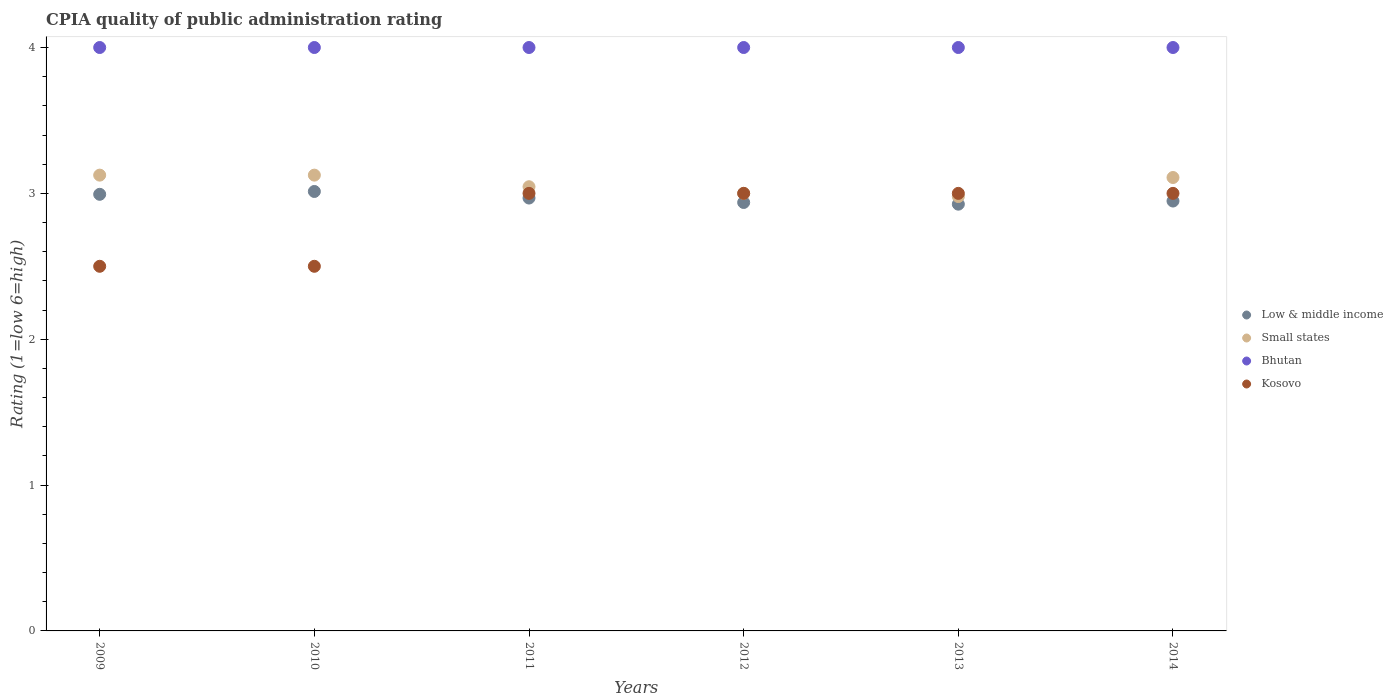What is the CPIA rating in Low & middle income in 2010?
Provide a succinct answer. 3.01. Across all years, what is the minimum CPIA rating in Kosovo?
Your response must be concise. 2.5. In which year was the CPIA rating in Small states minimum?
Your answer should be compact. 2013. What is the difference between the CPIA rating in Small states in 2014 and the CPIA rating in Low & middle income in 2010?
Give a very brief answer. 0.1. What is the average CPIA rating in Small states per year?
Make the answer very short. 3.06. In the year 2010, what is the difference between the CPIA rating in Kosovo and CPIA rating in Bhutan?
Your answer should be very brief. -1.5. In how many years, is the CPIA rating in Low & middle income greater than 2.2?
Your answer should be very brief. 6. What is the ratio of the CPIA rating in Low & middle income in 2011 to that in 2012?
Make the answer very short. 1.01. Is the difference between the CPIA rating in Kosovo in 2010 and 2013 greater than the difference between the CPIA rating in Bhutan in 2010 and 2013?
Keep it short and to the point. No. What is the difference between the highest and the lowest CPIA rating in Bhutan?
Provide a short and direct response. 0. In how many years, is the CPIA rating in Kosovo greater than the average CPIA rating in Kosovo taken over all years?
Provide a short and direct response. 4. Is the sum of the CPIA rating in Kosovo in 2010 and 2014 greater than the maximum CPIA rating in Low & middle income across all years?
Offer a terse response. Yes. Does the CPIA rating in Small states monotonically increase over the years?
Your answer should be compact. No. Is the CPIA rating in Small states strictly greater than the CPIA rating in Kosovo over the years?
Your answer should be very brief. No. Is the CPIA rating in Kosovo strictly less than the CPIA rating in Bhutan over the years?
Give a very brief answer. Yes. How many dotlines are there?
Provide a short and direct response. 4. How many years are there in the graph?
Offer a terse response. 6. Does the graph contain any zero values?
Ensure brevity in your answer.  No. Where does the legend appear in the graph?
Ensure brevity in your answer.  Center right. How many legend labels are there?
Provide a short and direct response. 4. What is the title of the graph?
Give a very brief answer. CPIA quality of public administration rating. What is the label or title of the Y-axis?
Offer a terse response. Rating (1=low 6=high). What is the Rating (1=low 6=high) of Low & middle income in 2009?
Provide a short and direct response. 2.99. What is the Rating (1=low 6=high) of Small states in 2009?
Keep it short and to the point. 3.12. What is the Rating (1=low 6=high) in Kosovo in 2009?
Your answer should be compact. 2.5. What is the Rating (1=low 6=high) of Low & middle income in 2010?
Your answer should be very brief. 3.01. What is the Rating (1=low 6=high) of Small states in 2010?
Your answer should be compact. 3.12. What is the Rating (1=low 6=high) in Bhutan in 2010?
Your response must be concise. 4. What is the Rating (1=low 6=high) of Kosovo in 2010?
Offer a very short reply. 2.5. What is the Rating (1=low 6=high) of Low & middle income in 2011?
Provide a short and direct response. 2.97. What is the Rating (1=low 6=high) of Small states in 2011?
Offer a terse response. 3.05. What is the Rating (1=low 6=high) of Kosovo in 2011?
Give a very brief answer. 3. What is the Rating (1=low 6=high) in Low & middle income in 2012?
Ensure brevity in your answer.  2.94. What is the Rating (1=low 6=high) of Small states in 2012?
Ensure brevity in your answer.  3. What is the Rating (1=low 6=high) of Kosovo in 2012?
Your answer should be very brief. 3. What is the Rating (1=low 6=high) of Low & middle income in 2013?
Provide a short and direct response. 2.93. What is the Rating (1=low 6=high) of Small states in 2013?
Make the answer very short. 2.98. What is the Rating (1=low 6=high) in Kosovo in 2013?
Ensure brevity in your answer.  3. What is the Rating (1=low 6=high) of Low & middle income in 2014?
Your answer should be very brief. 2.95. What is the Rating (1=low 6=high) in Small states in 2014?
Provide a succinct answer. 3.11. Across all years, what is the maximum Rating (1=low 6=high) of Low & middle income?
Offer a terse response. 3.01. Across all years, what is the maximum Rating (1=low 6=high) of Small states?
Your response must be concise. 3.12. Across all years, what is the maximum Rating (1=low 6=high) in Bhutan?
Offer a terse response. 4. Across all years, what is the maximum Rating (1=low 6=high) of Kosovo?
Your response must be concise. 3. Across all years, what is the minimum Rating (1=low 6=high) in Low & middle income?
Provide a short and direct response. 2.93. Across all years, what is the minimum Rating (1=low 6=high) in Small states?
Offer a very short reply. 2.98. Across all years, what is the minimum Rating (1=low 6=high) of Bhutan?
Provide a succinct answer. 4. What is the total Rating (1=low 6=high) in Low & middle income in the graph?
Offer a very short reply. 17.79. What is the total Rating (1=low 6=high) of Small states in the graph?
Your answer should be very brief. 18.38. What is the difference between the Rating (1=low 6=high) in Low & middle income in 2009 and that in 2010?
Give a very brief answer. -0.02. What is the difference between the Rating (1=low 6=high) of Bhutan in 2009 and that in 2010?
Your answer should be very brief. 0. What is the difference between the Rating (1=low 6=high) in Kosovo in 2009 and that in 2010?
Your response must be concise. 0. What is the difference between the Rating (1=low 6=high) in Low & middle income in 2009 and that in 2011?
Make the answer very short. 0.03. What is the difference between the Rating (1=low 6=high) of Small states in 2009 and that in 2011?
Give a very brief answer. 0.08. What is the difference between the Rating (1=low 6=high) in Bhutan in 2009 and that in 2011?
Your answer should be compact. 0. What is the difference between the Rating (1=low 6=high) of Low & middle income in 2009 and that in 2012?
Provide a succinct answer. 0.06. What is the difference between the Rating (1=low 6=high) of Small states in 2009 and that in 2012?
Make the answer very short. 0.12. What is the difference between the Rating (1=low 6=high) in Low & middle income in 2009 and that in 2013?
Provide a short and direct response. 0.07. What is the difference between the Rating (1=low 6=high) in Small states in 2009 and that in 2013?
Offer a terse response. 0.15. What is the difference between the Rating (1=low 6=high) of Low & middle income in 2009 and that in 2014?
Give a very brief answer. 0.05. What is the difference between the Rating (1=low 6=high) in Small states in 2009 and that in 2014?
Your answer should be very brief. 0.02. What is the difference between the Rating (1=low 6=high) in Bhutan in 2009 and that in 2014?
Your answer should be very brief. 0. What is the difference between the Rating (1=low 6=high) in Kosovo in 2009 and that in 2014?
Keep it short and to the point. -0.5. What is the difference between the Rating (1=low 6=high) in Low & middle income in 2010 and that in 2011?
Ensure brevity in your answer.  0.04. What is the difference between the Rating (1=low 6=high) in Small states in 2010 and that in 2011?
Offer a terse response. 0.08. What is the difference between the Rating (1=low 6=high) in Bhutan in 2010 and that in 2011?
Your answer should be compact. 0. What is the difference between the Rating (1=low 6=high) of Low & middle income in 2010 and that in 2012?
Your answer should be compact. 0.08. What is the difference between the Rating (1=low 6=high) in Low & middle income in 2010 and that in 2013?
Offer a terse response. 0.09. What is the difference between the Rating (1=low 6=high) in Small states in 2010 and that in 2013?
Provide a short and direct response. 0.15. What is the difference between the Rating (1=low 6=high) of Low & middle income in 2010 and that in 2014?
Offer a terse response. 0.07. What is the difference between the Rating (1=low 6=high) of Small states in 2010 and that in 2014?
Your response must be concise. 0.02. What is the difference between the Rating (1=low 6=high) of Kosovo in 2010 and that in 2014?
Offer a terse response. -0.5. What is the difference between the Rating (1=low 6=high) in Low & middle income in 2011 and that in 2012?
Provide a succinct answer. 0.03. What is the difference between the Rating (1=low 6=high) in Small states in 2011 and that in 2012?
Provide a short and direct response. 0.05. What is the difference between the Rating (1=low 6=high) of Kosovo in 2011 and that in 2012?
Offer a terse response. 0. What is the difference between the Rating (1=low 6=high) in Low & middle income in 2011 and that in 2013?
Keep it short and to the point. 0.04. What is the difference between the Rating (1=low 6=high) in Small states in 2011 and that in 2013?
Provide a succinct answer. 0.07. What is the difference between the Rating (1=low 6=high) in Bhutan in 2011 and that in 2013?
Provide a short and direct response. 0. What is the difference between the Rating (1=low 6=high) of Kosovo in 2011 and that in 2013?
Offer a terse response. 0. What is the difference between the Rating (1=low 6=high) in Low & middle income in 2011 and that in 2014?
Provide a short and direct response. 0.02. What is the difference between the Rating (1=low 6=high) in Small states in 2011 and that in 2014?
Make the answer very short. -0.06. What is the difference between the Rating (1=low 6=high) of Low & middle income in 2012 and that in 2013?
Ensure brevity in your answer.  0.01. What is the difference between the Rating (1=low 6=high) in Small states in 2012 and that in 2013?
Ensure brevity in your answer.  0.02. What is the difference between the Rating (1=low 6=high) of Kosovo in 2012 and that in 2013?
Keep it short and to the point. 0. What is the difference between the Rating (1=low 6=high) in Low & middle income in 2012 and that in 2014?
Give a very brief answer. -0.01. What is the difference between the Rating (1=low 6=high) of Small states in 2012 and that in 2014?
Your answer should be compact. -0.11. What is the difference between the Rating (1=low 6=high) of Bhutan in 2012 and that in 2014?
Your response must be concise. 0. What is the difference between the Rating (1=low 6=high) in Low & middle income in 2013 and that in 2014?
Offer a very short reply. -0.02. What is the difference between the Rating (1=low 6=high) in Small states in 2013 and that in 2014?
Keep it short and to the point. -0.13. What is the difference between the Rating (1=low 6=high) of Bhutan in 2013 and that in 2014?
Provide a succinct answer. 0. What is the difference between the Rating (1=low 6=high) of Kosovo in 2013 and that in 2014?
Make the answer very short. 0. What is the difference between the Rating (1=low 6=high) of Low & middle income in 2009 and the Rating (1=low 6=high) of Small states in 2010?
Ensure brevity in your answer.  -0.13. What is the difference between the Rating (1=low 6=high) of Low & middle income in 2009 and the Rating (1=low 6=high) of Bhutan in 2010?
Give a very brief answer. -1.01. What is the difference between the Rating (1=low 6=high) of Low & middle income in 2009 and the Rating (1=low 6=high) of Kosovo in 2010?
Your response must be concise. 0.49. What is the difference between the Rating (1=low 6=high) of Small states in 2009 and the Rating (1=low 6=high) of Bhutan in 2010?
Give a very brief answer. -0.88. What is the difference between the Rating (1=low 6=high) in Small states in 2009 and the Rating (1=low 6=high) in Kosovo in 2010?
Offer a very short reply. 0.62. What is the difference between the Rating (1=low 6=high) in Low & middle income in 2009 and the Rating (1=low 6=high) in Small states in 2011?
Make the answer very short. -0.05. What is the difference between the Rating (1=low 6=high) of Low & middle income in 2009 and the Rating (1=low 6=high) of Bhutan in 2011?
Provide a short and direct response. -1.01. What is the difference between the Rating (1=low 6=high) in Low & middle income in 2009 and the Rating (1=low 6=high) in Kosovo in 2011?
Your answer should be compact. -0.01. What is the difference between the Rating (1=low 6=high) of Small states in 2009 and the Rating (1=low 6=high) of Bhutan in 2011?
Keep it short and to the point. -0.88. What is the difference between the Rating (1=low 6=high) of Small states in 2009 and the Rating (1=low 6=high) of Kosovo in 2011?
Provide a succinct answer. 0.12. What is the difference between the Rating (1=low 6=high) in Low & middle income in 2009 and the Rating (1=low 6=high) in Small states in 2012?
Offer a very short reply. -0.01. What is the difference between the Rating (1=low 6=high) of Low & middle income in 2009 and the Rating (1=low 6=high) of Bhutan in 2012?
Give a very brief answer. -1.01. What is the difference between the Rating (1=low 6=high) of Low & middle income in 2009 and the Rating (1=low 6=high) of Kosovo in 2012?
Your response must be concise. -0.01. What is the difference between the Rating (1=low 6=high) of Small states in 2009 and the Rating (1=low 6=high) of Bhutan in 2012?
Ensure brevity in your answer.  -0.88. What is the difference between the Rating (1=low 6=high) of Small states in 2009 and the Rating (1=low 6=high) of Kosovo in 2012?
Give a very brief answer. 0.12. What is the difference between the Rating (1=low 6=high) of Low & middle income in 2009 and the Rating (1=low 6=high) of Small states in 2013?
Give a very brief answer. 0.02. What is the difference between the Rating (1=low 6=high) of Low & middle income in 2009 and the Rating (1=low 6=high) of Bhutan in 2013?
Provide a short and direct response. -1.01. What is the difference between the Rating (1=low 6=high) of Low & middle income in 2009 and the Rating (1=low 6=high) of Kosovo in 2013?
Your answer should be compact. -0.01. What is the difference between the Rating (1=low 6=high) in Small states in 2009 and the Rating (1=low 6=high) in Bhutan in 2013?
Your answer should be compact. -0.88. What is the difference between the Rating (1=low 6=high) of Small states in 2009 and the Rating (1=low 6=high) of Kosovo in 2013?
Ensure brevity in your answer.  0.12. What is the difference between the Rating (1=low 6=high) of Low & middle income in 2009 and the Rating (1=low 6=high) of Small states in 2014?
Make the answer very short. -0.12. What is the difference between the Rating (1=low 6=high) of Low & middle income in 2009 and the Rating (1=low 6=high) of Bhutan in 2014?
Make the answer very short. -1.01. What is the difference between the Rating (1=low 6=high) of Low & middle income in 2009 and the Rating (1=low 6=high) of Kosovo in 2014?
Offer a very short reply. -0.01. What is the difference between the Rating (1=low 6=high) of Small states in 2009 and the Rating (1=low 6=high) of Bhutan in 2014?
Ensure brevity in your answer.  -0.88. What is the difference between the Rating (1=low 6=high) in Bhutan in 2009 and the Rating (1=low 6=high) in Kosovo in 2014?
Ensure brevity in your answer.  1. What is the difference between the Rating (1=low 6=high) of Low & middle income in 2010 and the Rating (1=low 6=high) of Small states in 2011?
Provide a succinct answer. -0.03. What is the difference between the Rating (1=low 6=high) of Low & middle income in 2010 and the Rating (1=low 6=high) of Bhutan in 2011?
Ensure brevity in your answer.  -0.99. What is the difference between the Rating (1=low 6=high) of Low & middle income in 2010 and the Rating (1=low 6=high) of Kosovo in 2011?
Your response must be concise. 0.01. What is the difference between the Rating (1=low 6=high) in Small states in 2010 and the Rating (1=low 6=high) in Bhutan in 2011?
Provide a short and direct response. -0.88. What is the difference between the Rating (1=low 6=high) of Small states in 2010 and the Rating (1=low 6=high) of Kosovo in 2011?
Your answer should be very brief. 0.12. What is the difference between the Rating (1=low 6=high) in Bhutan in 2010 and the Rating (1=low 6=high) in Kosovo in 2011?
Offer a terse response. 1. What is the difference between the Rating (1=low 6=high) in Low & middle income in 2010 and the Rating (1=low 6=high) in Small states in 2012?
Offer a very short reply. 0.01. What is the difference between the Rating (1=low 6=high) of Low & middle income in 2010 and the Rating (1=low 6=high) of Bhutan in 2012?
Your answer should be compact. -0.99. What is the difference between the Rating (1=low 6=high) in Low & middle income in 2010 and the Rating (1=low 6=high) in Kosovo in 2012?
Your answer should be very brief. 0.01. What is the difference between the Rating (1=low 6=high) in Small states in 2010 and the Rating (1=low 6=high) in Bhutan in 2012?
Make the answer very short. -0.88. What is the difference between the Rating (1=low 6=high) of Low & middle income in 2010 and the Rating (1=low 6=high) of Small states in 2013?
Give a very brief answer. 0.03. What is the difference between the Rating (1=low 6=high) in Low & middle income in 2010 and the Rating (1=low 6=high) in Bhutan in 2013?
Keep it short and to the point. -0.99. What is the difference between the Rating (1=low 6=high) in Low & middle income in 2010 and the Rating (1=low 6=high) in Kosovo in 2013?
Provide a short and direct response. 0.01. What is the difference between the Rating (1=low 6=high) in Small states in 2010 and the Rating (1=low 6=high) in Bhutan in 2013?
Offer a terse response. -0.88. What is the difference between the Rating (1=low 6=high) of Bhutan in 2010 and the Rating (1=low 6=high) of Kosovo in 2013?
Your answer should be very brief. 1. What is the difference between the Rating (1=low 6=high) in Low & middle income in 2010 and the Rating (1=low 6=high) in Small states in 2014?
Your response must be concise. -0.1. What is the difference between the Rating (1=low 6=high) of Low & middle income in 2010 and the Rating (1=low 6=high) of Bhutan in 2014?
Offer a terse response. -0.99. What is the difference between the Rating (1=low 6=high) of Low & middle income in 2010 and the Rating (1=low 6=high) of Kosovo in 2014?
Keep it short and to the point. 0.01. What is the difference between the Rating (1=low 6=high) of Small states in 2010 and the Rating (1=low 6=high) of Bhutan in 2014?
Ensure brevity in your answer.  -0.88. What is the difference between the Rating (1=low 6=high) of Small states in 2010 and the Rating (1=low 6=high) of Kosovo in 2014?
Keep it short and to the point. 0.12. What is the difference between the Rating (1=low 6=high) in Low & middle income in 2011 and the Rating (1=low 6=high) in Small states in 2012?
Offer a very short reply. -0.03. What is the difference between the Rating (1=low 6=high) in Low & middle income in 2011 and the Rating (1=low 6=high) in Bhutan in 2012?
Provide a short and direct response. -1.03. What is the difference between the Rating (1=low 6=high) in Low & middle income in 2011 and the Rating (1=low 6=high) in Kosovo in 2012?
Offer a very short reply. -0.03. What is the difference between the Rating (1=low 6=high) of Small states in 2011 and the Rating (1=low 6=high) of Bhutan in 2012?
Make the answer very short. -0.95. What is the difference between the Rating (1=low 6=high) of Small states in 2011 and the Rating (1=low 6=high) of Kosovo in 2012?
Offer a terse response. 0.05. What is the difference between the Rating (1=low 6=high) in Low & middle income in 2011 and the Rating (1=low 6=high) in Small states in 2013?
Ensure brevity in your answer.  -0.01. What is the difference between the Rating (1=low 6=high) in Low & middle income in 2011 and the Rating (1=low 6=high) in Bhutan in 2013?
Keep it short and to the point. -1.03. What is the difference between the Rating (1=low 6=high) in Low & middle income in 2011 and the Rating (1=low 6=high) in Kosovo in 2013?
Your answer should be very brief. -0.03. What is the difference between the Rating (1=low 6=high) of Small states in 2011 and the Rating (1=low 6=high) of Bhutan in 2013?
Give a very brief answer. -0.95. What is the difference between the Rating (1=low 6=high) in Small states in 2011 and the Rating (1=low 6=high) in Kosovo in 2013?
Provide a succinct answer. 0.05. What is the difference between the Rating (1=low 6=high) in Bhutan in 2011 and the Rating (1=low 6=high) in Kosovo in 2013?
Offer a very short reply. 1. What is the difference between the Rating (1=low 6=high) in Low & middle income in 2011 and the Rating (1=low 6=high) in Small states in 2014?
Provide a short and direct response. -0.14. What is the difference between the Rating (1=low 6=high) of Low & middle income in 2011 and the Rating (1=low 6=high) of Bhutan in 2014?
Ensure brevity in your answer.  -1.03. What is the difference between the Rating (1=low 6=high) of Low & middle income in 2011 and the Rating (1=low 6=high) of Kosovo in 2014?
Keep it short and to the point. -0.03. What is the difference between the Rating (1=low 6=high) of Small states in 2011 and the Rating (1=low 6=high) of Bhutan in 2014?
Give a very brief answer. -0.95. What is the difference between the Rating (1=low 6=high) in Small states in 2011 and the Rating (1=low 6=high) in Kosovo in 2014?
Your answer should be compact. 0.05. What is the difference between the Rating (1=low 6=high) in Low & middle income in 2012 and the Rating (1=low 6=high) in Small states in 2013?
Ensure brevity in your answer.  -0.04. What is the difference between the Rating (1=low 6=high) in Low & middle income in 2012 and the Rating (1=low 6=high) in Bhutan in 2013?
Your answer should be very brief. -1.06. What is the difference between the Rating (1=low 6=high) of Low & middle income in 2012 and the Rating (1=low 6=high) of Kosovo in 2013?
Your answer should be compact. -0.06. What is the difference between the Rating (1=low 6=high) in Small states in 2012 and the Rating (1=low 6=high) in Bhutan in 2013?
Your answer should be compact. -1. What is the difference between the Rating (1=low 6=high) in Small states in 2012 and the Rating (1=low 6=high) in Kosovo in 2013?
Your response must be concise. 0. What is the difference between the Rating (1=low 6=high) in Bhutan in 2012 and the Rating (1=low 6=high) in Kosovo in 2013?
Ensure brevity in your answer.  1. What is the difference between the Rating (1=low 6=high) of Low & middle income in 2012 and the Rating (1=low 6=high) of Small states in 2014?
Your answer should be compact. -0.17. What is the difference between the Rating (1=low 6=high) of Low & middle income in 2012 and the Rating (1=low 6=high) of Bhutan in 2014?
Provide a short and direct response. -1.06. What is the difference between the Rating (1=low 6=high) in Low & middle income in 2012 and the Rating (1=low 6=high) in Kosovo in 2014?
Your answer should be compact. -0.06. What is the difference between the Rating (1=low 6=high) in Bhutan in 2012 and the Rating (1=low 6=high) in Kosovo in 2014?
Your answer should be compact. 1. What is the difference between the Rating (1=low 6=high) of Low & middle income in 2013 and the Rating (1=low 6=high) of Small states in 2014?
Your response must be concise. -0.18. What is the difference between the Rating (1=low 6=high) in Low & middle income in 2013 and the Rating (1=low 6=high) in Bhutan in 2014?
Your response must be concise. -1.07. What is the difference between the Rating (1=low 6=high) in Low & middle income in 2013 and the Rating (1=low 6=high) in Kosovo in 2014?
Your answer should be very brief. -0.07. What is the difference between the Rating (1=low 6=high) of Small states in 2013 and the Rating (1=low 6=high) of Bhutan in 2014?
Offer a very short reply. -1.02. What is the difference between the Rating (1=low 6=high) in Small states in 2013 and the Rating (1=low 6=high) in Kosovo in 2014?
Your answer should be compact. -0.02. What is the average Rating (1=low 6=high) of Low & middle income per year?
Give a very brief answer. 2.96. What is the average Rating (1=low 6=high) of Small states per year?
Your response must be concise. 3.06. What is the average Rating (1=low 6=high) of Kosovo per year?
Your answer should be compact. 2.83. In the year 2009, what is the difference between the Rating (1=low 6=high) in Low & middle income and Rating (1=low 6=high) in Small states?
Provide a succinct answer. -0.13. In the year 2009, what is the difference between the Rating (1=low 6=high) in Low & middle income and Rating (1=low 6=high) in Bhutan?
Keep it short and to the point. -1.01. In the year 2009, what is the difference between the Rating (1=low 6=high) of Low & middle income and Rating (1=low 6=high) of Kosovo?
Give a very brief answer. 0.49. In the year 2009, what is the difference between the Rating (1=low 6=high) in Small states and Rating (1=low 6=high) in Bhutan?
Give a very brief answer. -0.88. In the year 2009, what is the difference between the Rating (1=low 6=high) in Bhutan and Rating (1=low 6=high) in Kosovo?
Offer a terse response. 1.5. In the year 2010, what is the difference between the Rating (1=low 6=high) of Low & middle income and Rating (1=low 6=high) of Small states?
Offer a very short reply. -0.11. In the year 2010, what is the difference between the Rating (1=low 6=high) in Low & middle income and Rating (1=low 6=high) in Bhutan?
Make the answer very short. -0.99. In the year 2010, what is the difference between the Rating (1=low 6=high) in Low & middle income and Rating (1=low 6=high) in Kosovo?
Make the answer very short. 0.51. In the year 2010, what is the difference between the Rating (1=low 6=high) of Small states and Rating (1=low 6=high) of Bhutan?
Keep it short and to the point. -0.88. In the year 2010, what is the difference between the Rating (1=low 6=high) in Bhutan and Rating (1=low 6=high) in Kosovo?
Provide a succinct answer. 1.5. In the year 2011, what is the difference between the Rating (1=low 6=high) in Low & middle income and Rating (1=low 6=high) in Small states?
Offer a very short reply. -0.08. In the year 2011, what is the difference between the Rating (1=low 6=high) in Low & middle income and Rating (1=low 6=high) in Bhutan?
Give a very brief answer. -1.03. In the year 2011, what is the difference between the Rating (1=low 6=high) in Low & middle income and Rating (1=low 6=high) in Kosovo?
Your answer should be compact. -0.03. In the year 2011, what is the difference between the Rating (1=low 6=high) of Small states and Rating (1=low 6=high) of Bhutan?
Your answer should be compact. -0.95. In the year 2011, what is the difference between the Rating (1=low 6=high) of Small states and Rating (1=low 6=high) of Kosovo?
Make the answer very short. 0.05. In the year 2012, what is the difference between the Rating (1=low 6=high) of Low & middle income and Rating (1=low 6=high) of Small states?
Provide a succinct answer. -0.06. In the year 2012, what is the difference between the Rating (1=low 6=high) in Low & middle income and Rating (1=low 6=high) in Bhutan?
Ensure brevity in your answer.  -1.06. In the year 2012, what is the difference between the Rating (1=low 6=high) of Low & middle income and Rating (1=low 6=high) of Kosovo?
Provide a short and direct response. -0.06. In the year 2012, what is the difference between the Rating (1=low 6=high) of Small states and Rating (1=low 6=high) of Bhutan?
Offer a very short reply. -1. In the year 2013, what is the difference between the Rating (1=low 6=high) in Low & middle income and Rating (1=low 6=high) in Small states?
Provide a short and direct response. -0.05. In the year 2013, what is the difference between the Rating (1=low 6=high) in Low & middle income and Rating (1=low 6=high) in Bhutan?
Provide a short and direct response. -1.07. In the year 2013, what is the difference between the Rating (1=low 6=high) in Low & middle income and Rating (1=low 6=high) in Kosovo?
Your response must be concise. -0.07. In the year 2013, what is the difference between the Rating (1=low 6=high) in Small states and Rating (1=low 6=high) in Bhutan?
Offer a very short reply. -1.02. In the year 2013, what is the difference between the Rating (1=low 6=high) of Small states and Rating (1=low 6=high) of Kosovo?
Keep it short and to the point. -0.02. In the year 2014, what is the difference between the Rating (1=low 6=high) of Low & middle income and Rating (1=low 6=high) of Small states?
Your response must be concise. -0.16. In the year 2014, what is the difference between the Rating (1=low 6=high) of Low & middle income and Rating (1=low 6=high) of Bhutan?
Keep it short and to the point. -1.05. In the year 2014, what is the difference between the Rating (1=low 6=high) in Low & middle income and Rating (1=low 6=high) in Kosovo?
Ensure brevity in your answer.  -0.05. In the year 2014, what is the difference between the Rating (1=low 6=high) in Small states and Rating (1=low 6=high) in Bhutan?
Your response must be concise. -0.89. In the year 2014, what is the difference between the Rating (1=low 6=high) in Small states and Rating (1=low 6=high) in Kosovo?
Your answer should be very brief. 0.11. What is the ratio of the Rating (1=low 6=high) of Low & middle income in 2009 to that in 2010?
Provide a short and direct response. 0.99. What is the ratio of the Rating (1=low 6=high) of Small states in 2009 to that in 2010?
Your answer should be compact. 1. What is the ratio of the Rating (1=low 6=high) in Bhutan in 2009 to that in 2010?
Ensure brevity in your answer.  1. What is the ratio of the Rating (1=low 6=high) of Kosovo in 2009 to that in 2010?
Provide a short and direct response. 1. What is the ratio of the Rating (1=low 6=high) of Low & middle income in 2009 to that in 2011?
Ensure brevity in your answer.  1.01. What is the ratio of the Rating (1=low 6=high) of Small states in 2009 to that in 2011?
Your response must be concise. 1.03. What is the ratio of the Rating (1=low 6=high) in Bhutan in 2009 to that in 2011?
Your response must be concise. 1. What is the ratio of the Rating (1=low 6=high) of Low & middle income in 2009 to that in 2012?
Offer a very short reply. 1.02. What is the ratio of the Rating (1=low 6=high) of Small states in 2009 to that in 2012?
Give a very brief answer. 1.04. What is the ratio of the Rating (1=low 6=high) in Low & middle income in 2009 to that in 2013?
Make the answer very short. 1.02. What is the ratio of the Rating (1=low 6=high) of Small states in 2009 to that in 2013?
Your answer should be compact. 1.05. What is the ratio of the Rating (1=low 6=high) of Low & middle income in 2009 to that in 2014?
Offer a terse response. 1.02. What is the ratio of the Rating (1=low 6=high) of Low & middle income in 2010 to that in 2011?
Keep it short and to the point. 1.02. What is the ratio of the Rating (1=low 6=high) in Small states in 2010 to that in 2011?
Your response must be concise. 1.03. What is the ratio of the Rating (1=low 6=high) in Bhutan in 2010 to that in 2011?
Your response must be concise. 1. What is the ratio of the Rating (1=low 6=high) in Kosovo in 2010 to that in 2011?
Give a very brief answer. 0.83. What is the ratio of the Rating (1=low 6=high) in Low & middle income in 2010 to that in 2012?
Keep it short and to the point. 1.03. What is the ratio of the Rating (1=low 6=high) of Small states in 2010 to that in 2012?
Make the answer very short. 1.04. What is the ratio of the Rating (1=low 6=high) in Bhutan in 2010 to that in 2012?
Provide a succinct answer. 1. What is the ratio of the Rating (1=low 6=high) of Kosovo in 2010 to that in 2012?
Your answer should be very brief. 0.83. What is the ratio of the Rating (1=low 6=high) of Low & middle income in 2010 to that in 2013?
Keep it short and to the point. 1.03. What is the ratio of the Rating (1=low 6=high) in Small states in 2010 to that in 2013?
Your answer should be very brief. 1.05. What is the ratio of the Rating (1=low 6=high) in Low & middle income in 2010 to that in 2014?
Give a very brief answer. 1.02. What is the ratio of the Rating (1=low 6=high) of Small states in 2010 to that in 2014?
Your answer should be compact. 1.01. What is the ratio of the Rating (1=low 6=high) in Bhutan in 2010 to that in 2014?
Offer a very short reply. 1. What is the ratio of the Rating (1=low 6=high) in Kosovo in 2010 to that in 2014?
Give a very brief answer. 0.83. What is the ratio of the Rating (1=low 6=high) in Low & middle income in 2011 to that in 2012?
Offer a terse response. 1.01. What is the ratio of the Rating (1=low 6=high) in Small states in 2011 to that in 2012?
Give a very brief answer. 1.02. What is the ratio of the Rating (1=low 6=high) of Bhutan in 2011 to that in 2012?
Offer a terse response. 1. What is the ratio of the Rating (1=low 6=high) of Kosovo in 2011 to that in 2012?
Ensure brevity in your answer.  1. What is the ratio of the Rating (1=low 6=high) of Low & middle income in 2011 to that in 2013?
Your answer should be compact. 1.01. What is the ratio of the Rating (1=low 6=high) in Small states in 2011 to that in 2013?
Ensure brevity in your answer.  1.02. What is the ratio of the Rating (1=low 6=high) in Bhutan in 2011 to that in 2013?
Make the answer very short. 1. What is the ratio of the Rating (1=low 6=high) of Kosovo in 2011 to that in 2013?
Make the answer very short. 1. What is the ratio of the Rating (1=low 6=high) in Low & middle income in 2011 to that in 2014?
Your answer should be compact. 1.01. What is the ratio of the Rating (1=low 6=high) of Small states in 2011 to that in 2014?
Keep it short and to the point. 0.98. What is the ratio of the Rating (1=low 6=high) in Kosovo in 2011 to that in 2014?
Your answer should be very brief. 1. What is the ratio of the Rating (1=low 6=high) of Low & middle income in 2012 to that in 2013?
Provide a succinct answer. 1. What is the ratio of the Rating (1=low 6=high) of Small states in 2012 to that in 2013?
Provide a succinct answer. 1.01. What is the ratio of the Rating (1=low 6=high) of Low & middle income in 2012 to that in 2014?
Provide a succinct answer. 1. What is the ratio of the Rating (1=low 6=high) of Kosovo in 2012 to that in 2014?
Keep it short and to the point. 1. What is the ratio of the Rating (1=low 6=high) of Small states in 2013 to that in 2014?
Offer a terse response. 0.96. What is the ratio of the Rating (1=low 6=high) of Bhutan in 2013 to that in 2014?
Keep it short and to the point. 1. What is the difference between the highest and the second highest Rating (1=low 6=high) in Low & middle income?
Your answer should be very brief. 0.02. What is the difference between the highest and the second highest Rating (1=low 6=high) in Small states?
Your answer should be very brief. 0. What is the difference between the highest and the second highest Rating (1=low 6=high) in Bhutan?
Your answer should be very brief. 0. What is the difference between the highest and the second highest Rating (1=low 6=high) of Kosovo?
Provide a short and direct response. 0. What is the difference between the highest and the lowest Rating (1=low 6=high) of Low & middle income?
Give a very brief answer. 0.09. What is the difference between the highest and the lowest Rating (1=low 6=high) in Small states?
Make the answer very short. 0.15. What is the difference between the highest and the lowest Rating (1=low 6=high) of Kosovo?
Offer a terse response. 0.5. 